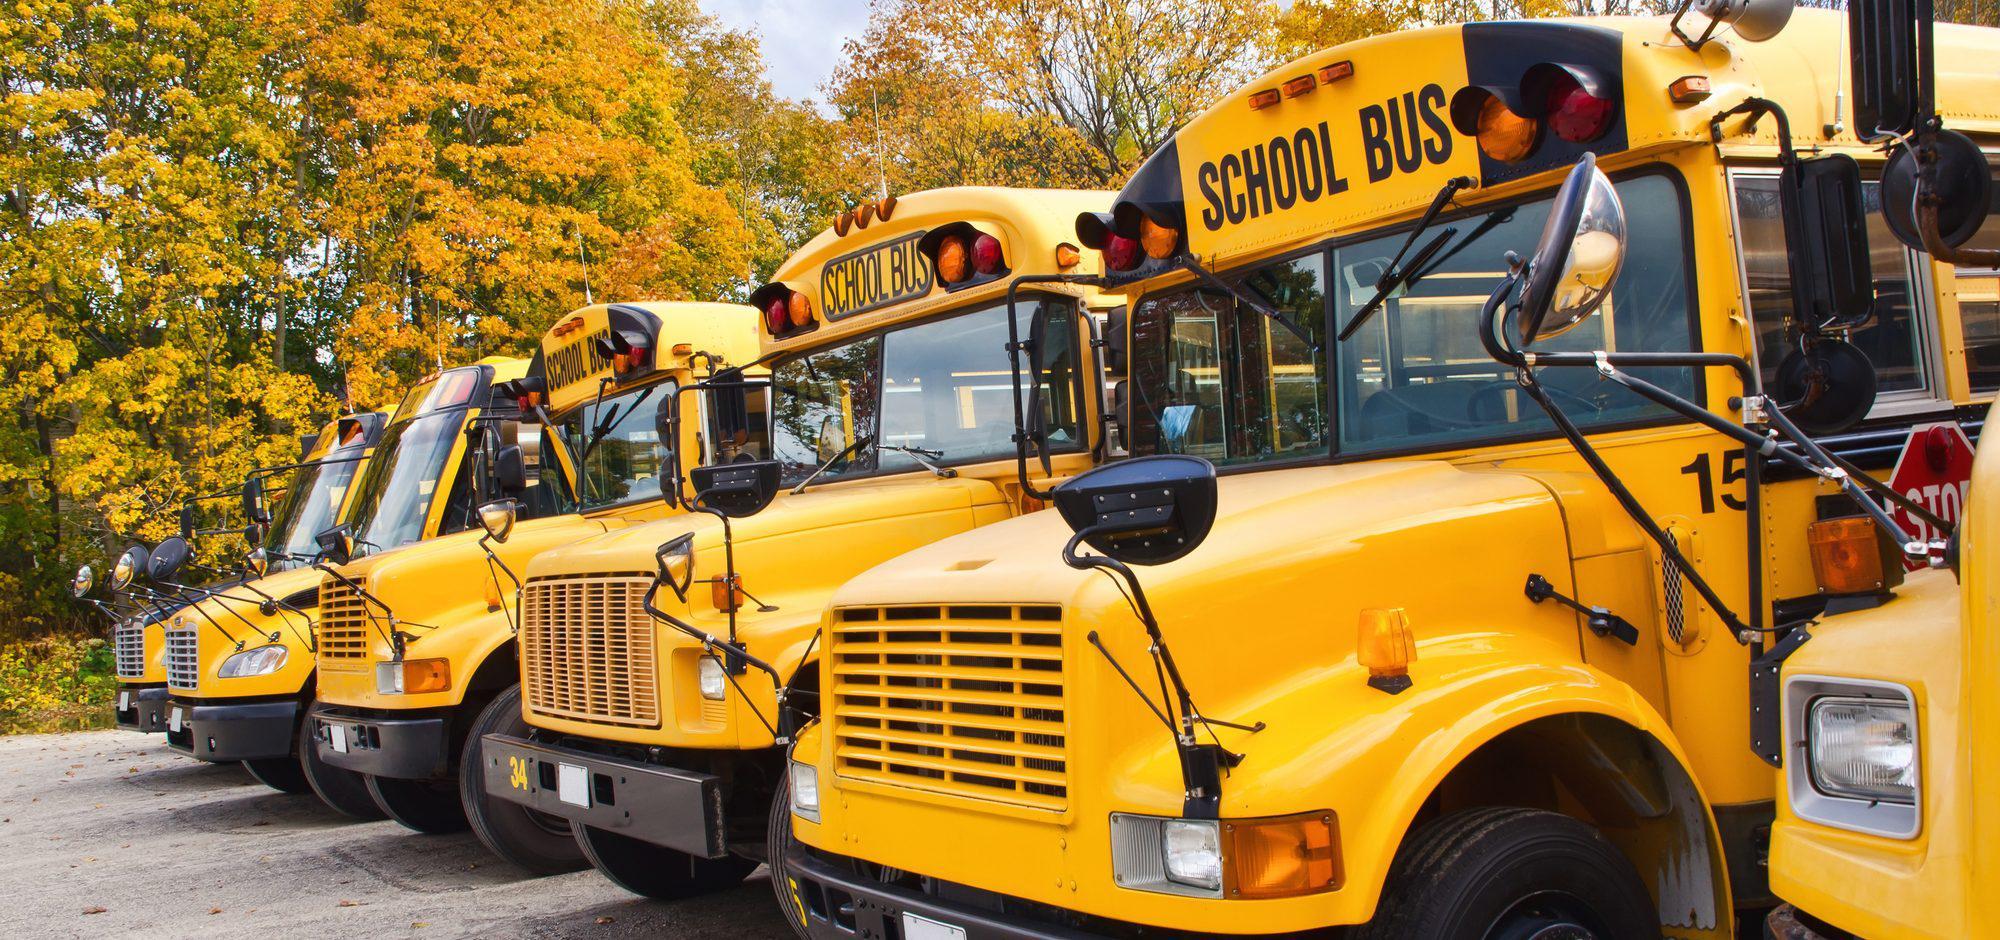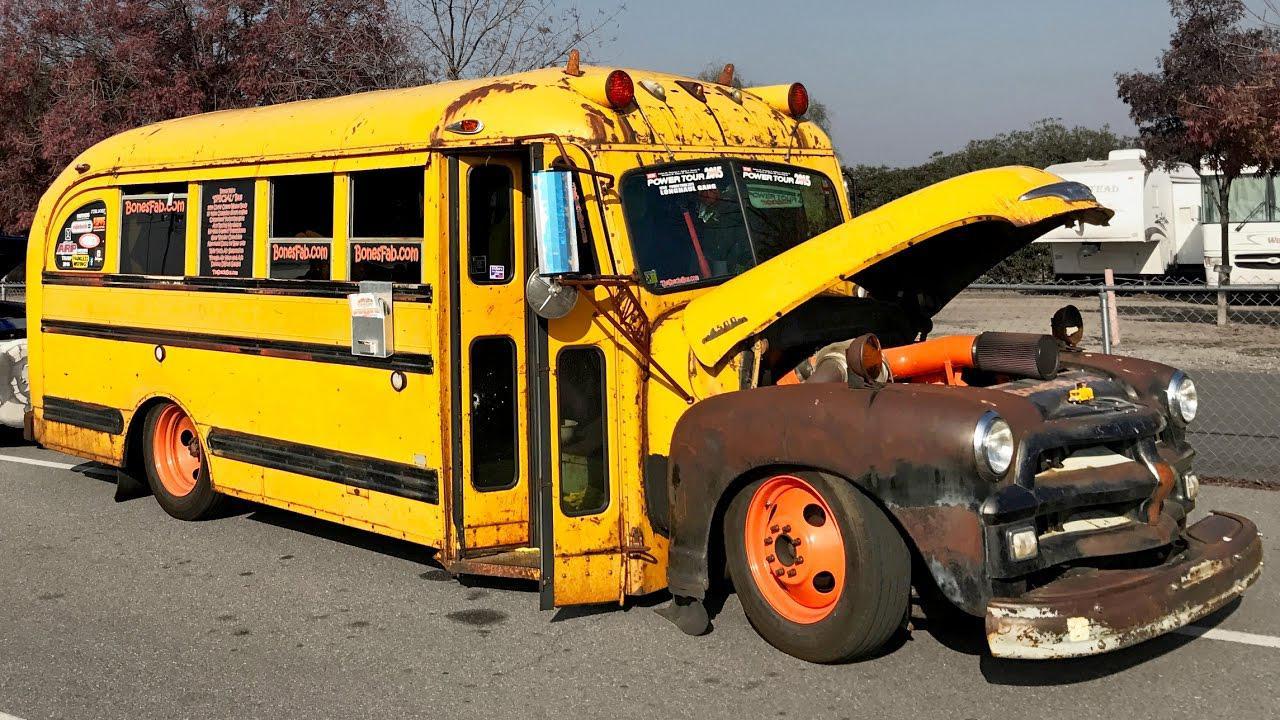The first image is the image on the left, the second image is the image on the right. For the images displayed, is the sentence "In the left image, one person is in front of the open side-entry passenger door of a bus." factually correct? Answer yes or no. No. The first image is the image on the left, the second image is the image on the right. Given the left and right images, does the statement "One image shows schoolbuses parked next to each other facing rightward." hold true? Answer yes or no. No. 